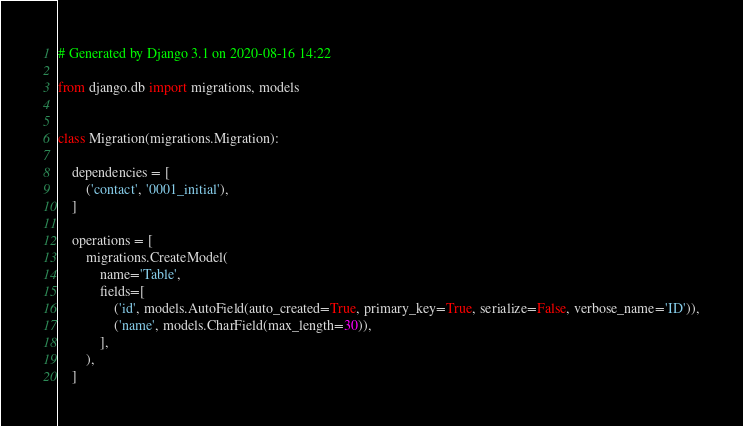<code> <loc_0><loc_0><loc_500><loc_500><_Python_># Generated by Django 3.1 on 2020-08-16 14:22

from django.db import migrations, models


class Migration(migrations.Migration):

    dependencies = [
        ('contact', '0001_initial'),
    ]

    operations = [
        migrations.CreateModel(
            name='Table',
            fields=[
                ('id', models.AutoField(auto_created=True, primary_key=True, serialize=False, verbose_name='ID')),
                ('name', models.CharField(max_length=30)),
            ],
        ),
    ]
</code> 